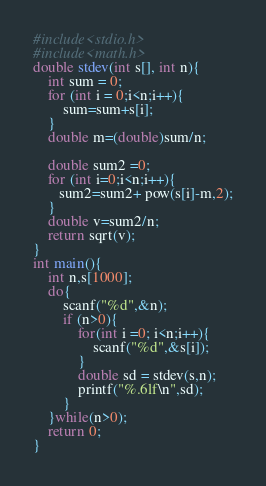Convert code to text. <code><loc_0><loc_0><loc_500><loc_500><_C_>#include<stdio.h>
#include<math.h>
double stdev(int s[], int n){
    int sum = 0;
    for (int i = 0;i<n;i++){
        sum=sum+s[i];
    }
    double m=(double)sum/n;
    
    double sum2 =0;
    for (int i=0;i<n;i++){
       sum2=sum2+ pow(s[i]-m,2);
    }
    double v=sum2/n;
    return sqrt(v);
}
int main(){
    int n,s[1000];
    do{
        scanf("%d",&n);
        if (n>0){
            for(int i =0; i<n;i++){
                scanf("%d",&s[i]);
            }
            double sd = stdev(s,n);
            printf("%.6lf\n",sd);
        }
    }while(n>0);
    return 0;
}
</code> 